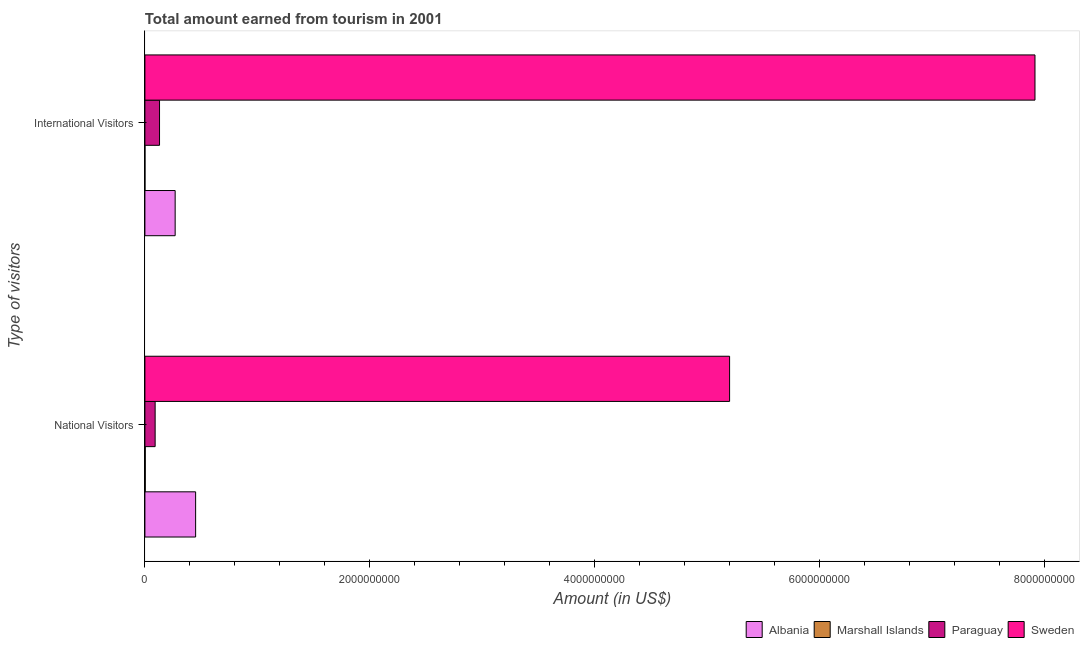How many groups of bars are there?
Provide a short and direct response. 2. Are the number of bars per tick equal to the number of legend labels?
Provide a short and direct response. Yes. Are the number of bars on each tick of the Y-axis equal?
Provide a short and direct response. Yes. How many bars are there on the 2nd tick from the top?
Give a very brief answer. 4. What is the label of the 1st group of bars from the top?
Provide a short and direct response. International Visitors. What is the amount earned from national visitors in Albania?
Your response must be concise. 4.51e+08. Across all countries, what is the maximum amount earned from international visitors?
Your answer should be very brief. 7.92e+09. Across all countries, what is the minimum amount earned from national visitors?
Provide a short and direct response. 3.10e+06. In which country was the amount earned from international visitors minimum?
Give a very brief answer. Marshall Islands. What is the total amount earned from international visitors in the graph?
Your answer should be very brief. 8.32e+09. What is the difference between the amount earned from national visitors in Albania and that in Paraguay?
Offer a terse response. 3.60e+08. What is the difference between the amount earned from international visitors in Albania and the amount earned from national visitors in Marshall Islands?
Give a very brief answer. 2.66e+08. What is the average amount earned from international visitors per country?
Your answer should be compact. 2.08e+09. What is the difference between the amount earned from national visitors and amount earned from international visitors in Marshall Islands?
Ensure brevity in your answer.  2.80e+06. In how many countries, is the amount earned from national visitors greater than 4800000000 US$?
Offer a terse response. 1. What is the ratio of the amount earned from national visitors in Marshall Islands to that in Albania?
Your answer should be compact. 0.01. Is the amount earned from national visitors in Sweden less than that in Paraguay?
Make the answer very short. No. What does the 3rd bar from the top in International Visitors represents?
Your answer should be very brief. Marshall Islands. What does the 2nd bar from the bottom in National Visitors represents?
Keep it short and to the point. Marshall Islands. How many countries are there in the graph?
Provide a short and direct response. 4. What is the difference between two consecutive major ticks on the X-axis?
Your response must be concise. 2.00e+09. Where does the legend appear in the graph?
Your response must be concise. Bottom right. What is the title of the graph?
Make the answer very short. Total amount earned from tourism in 2001. What is the label or title of the X-axis?
Offer a very short reply. Amount (in US$). What is the label or title of the Y-axis?
Offer a terse response. Type of visitors. What is the Amount (in US$) of Albania in National Visitors?
Offer a terse response. 4.51e+08. What is the Amount (in US$) in Marshall Islands in National Visitors?
Give a very brief answer. 3.10e+06. What is the Amount (in US$) in Paraguay in National Visitors?
Keep it short and to the point. 9.10e+07. What is the Amount (in US$) of Sweden in National Visitors?
Make the answer very short. 5.20e+09. What is the Amount (in US$) in Albania in International Visitors?
Ensure brevity in your answer.  2.69e+08. What is the Amount (in US$) of Marshall Islands in International Visitors?
Provide a succinct answer. 3.00e+05. What is the Amount (in US$) in Paraguay in International Visitors?
Offer a terse response. 1.30e+08. What is the Amount (in US$) in Sweden in International Visitors?
Your response must be concise. 7.92e+09. Across all Type of visitors, what is the maximum Amount (in US$) of Albania?
Provide a short and direct response. 4.51e+08. Across all Type of visitors, what is the maximum Amount (in US$) in Marshall Islands?
Offer a terse response. 3.10e+06. Across all Type of visitors, what is the maximum Amount (in US$) of Paraguay?
Provide a short and direct response. 1.30e+08. Across all Type of visitors, what is the maximum Amount (in US$) in Sweden?
Offer a terse response. 7.92e+09. Across all Type of visitors, what is the minimum Amount (in US$) of Albania?
Provide a short and direct response. 2.69e+08. Across all Type of visitors, what is the minimum Amount (in US$) of Paraguay?
Your answer should be very brief. 9.10e+07. Across all Type of visitors, what is the minimum Amount (in US$) in Sweden?
Ensure brevity in your answer.  5.20e+09. What is the total Amount (in US$) of Albania in the graph?
Offer a terse response. 7.20e+08. What is the total Amount (in US$) in Marshall Islands in the graph?
Offer a very short reply. 3.40e+06. What is the total Amount (in US$) in Paraguay in the graph?
Provide a short and direct response. 2.21e+08. What is the total Amount (in US$) in Sweden in the graph?
Make the answer very short. 1.31e+1. What is the difference between the Amount (in US$) in Albania in National Visitors and that in International Visitors?
Provide a succinct answer. 1.82e+08. What is the difference between the Amount (in US$) in Marshall Islands in National Visitors and that in International Visitors?
Your answer should be compact. 2.80e+06. What is the difference between the Amount (in US$) of Paraguay in National Visitors and that in International Visitors?
Offer a very short reply. -3.90e+07. What is the difference between the Amount (in US$) of Sweden in National Visitors and that in International Visitors?
Your answer should be very brief. -2.72e+09. What is the difference between the Amount (in US$) of Albania in National Visitors and the Amount (in US$) of Marshall Islands in International Visitors?
Provide a succinct answer. 4.51e+08. What is the difference between the Amount (in US$) in Albania in National Visitors and the Amount (in US$) in Paraguay in International Visitors?
Your response must be concise. 3.21e+08. What is the difference between the Amount (in US$) in Albania in National Visitors and the Amount (in US$) in Sweden in International Visitors?
Give a very brief answer. -7.46e+09. What is the difference between the Amount (in US$) of Marshall Islands in National Visitors and the Amount (in US$) of Paraguay in International Visitors?
Make the answer very short. -1.27e+08. What is the difference between the Amount (in US$) in Marshall Islands in National Visitors and the Amount (in US$) in Sweden in International Visitors?
Keep it short and to the point. -7.91e+09. What is the difference between the Amount (in US$) in Paraguay in National Visitors and the Amount (in US$) in Sweden in International Visitors?
Provide a short and direct response. -7.82e+09. What is the average Amount (in US$) in Albania per Type of visitors?
Your answer should be compact. 3.60e+08. What is the average Amount (in US$) in Marshall Islands per Type of visitors?
Provide a succinct answer. 1.70e+06. What is the average Amount (in US$) of Paraguay per Type of visitors?
Make the answer very short. 1.10e+08. What is the average Amount (in US$) in Sweden per Type of visitors?
Your answer should be very brief. 6.56e+09. What is the difference between the Amount (in US$) in Albania and Amount (in US$) in Marshall Islands in National Visitors?
Offer a terse response. 4.48e+08. What is the difference between the Amount (in US$) of Albania and Amount (in US$) of Paraguay in National Visitors?
Keep it short and to the point. 3.60e+08. What is the difference between the Amount (in US$) in Albania and Amount (in US$) in Sweden in National Visitors?
Make the answer very short. -4.75e+09. What is the difference between the Amount (in US$) of Marshall Islands and Amount (in US$) of Paraguay in National Visitors?
Your response must be concise. -8.79e+07. What is the difference between the Amount (in US$) of Marshall Islands and Amount (in US$) of Sweden in National Visitors?
Give a very brief answer. -5.20e+09. What is the difference between the Amount (in US$) of Paraguay and Amount (in US$) of Sweden in National Visitors?
Give a very brief answer. -5.11e+09. What is the difference between the Amount (in US$) of Albania and Amount (in US$) of Marshall Islands in International Visitors?
Offer a very short reply. 2.69e+08. What is the difference between the Amount (in US$) of Albania and Amount (in US$) of Paraguay in International Visitors?
Provide a succinct answer. 1.39e+08. What is the difference between the Amount (in US$) of Albania and Amount (in US$) of Sweden in International Visitors?
Ensure brevity in your answer.  -7.65e+09. What is the difference between the Amount (in US$) of Marshall Islands and Amount (in US$) of Paraguay in International Visitors?
Provide a short and direct response. -1.30e+08. What is the difference between the Amount (in US$) of Marshall Islands and Amount (in US$) of Sweden in International Visitors?
Provide a succinct answer. -7.92e+09. What is the difference between the Amount (in US$) of Paraguay and Amount (in US$) of Sweden in International Visitors?
Ensure brevity in your answer.  -7.79e+09. What is the ratio of the Amount (in US$) in Albania in National Visitors to that in International Visitors?
Offer a very short reply. 1.68. What is the ratio of the Amount (in US$) of Marshall Islands in National Visitors to that in International Visitors?
Keep it short and to the point. 10.33. What is the ratio of the Amount (in US$) of Paraguay in National Visitors to that in International Visitors?
Provide a succinct answer. 0.7. What is the ratio of the Amount (in US$) in Sweden in National Visitors to that in International Visitors?
Keep it short and to the point. 0.66. What is the difference between the highest and the second highest Amount (in US$) of Albania?
Give a very brief answer. 1.82e+08. What is the difference between the highest and the second highest Amount (in US$) in Marshall Islands?
Offer a terse response. 2.80e+06. What is the difference between the highest and the second highest Amount (in US$) of Paraguay?
Your response must be concise. 3.90e+07. What is the difference between the highest and the second highest Amount (in US$) in Sweden?
Offer a very short reply. 2.72e+09. What is the difference between the highest and the lowest Amount (in US$) of Albania?
Your answer should be very brief. 1.82e+08. What is the difference between the highest and the lowest Amount (in US$) in Marshall Islands?
Your answer should be very brief. 2.80e+06. What is the difference between the highest and the lowest Amount (in US$) in Paraguay?
Provide a succinct answer. 3.90e+07. What is the difference between the highest and the lowest Amount (in US$) in Sweden?
Your answer should be very brief. 2.72e+09. 